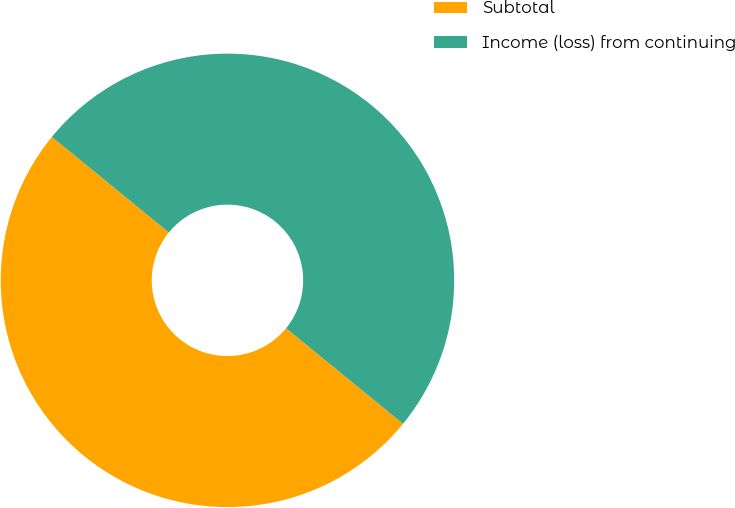Convert chart to OTSL. <chart><loc_0><loc_0><loc_500><loc_500><pie_chart><fcel>Subtotal<fcel>Income (loss) from continuing<nl><fcel>50.0%<fcel>50.0%<nl></chart> 